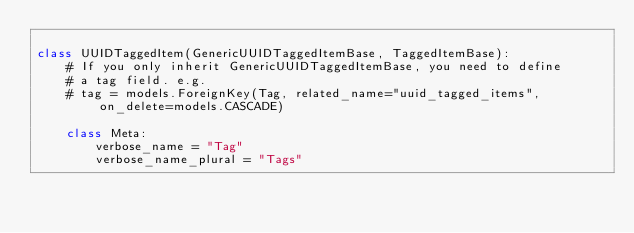<code> <loc_0><loc_0><loc_500><loc_500><_Python_>
class UUIDTaggedItem(GenericUUIDTaggedItemBase, TaggedItemBase):
    # If you only inherit GenericUUIDTaggedItemBase, you need to define
    # a tag field. e.g.
    # tag = models.ForeignKey(Tag, related_name="uuid_tagged_items", on_delete=models.CASCADE)

    class Meta:
        verbose_name = "Tag"
        verbose_name_plural = "Tags"
</code> 